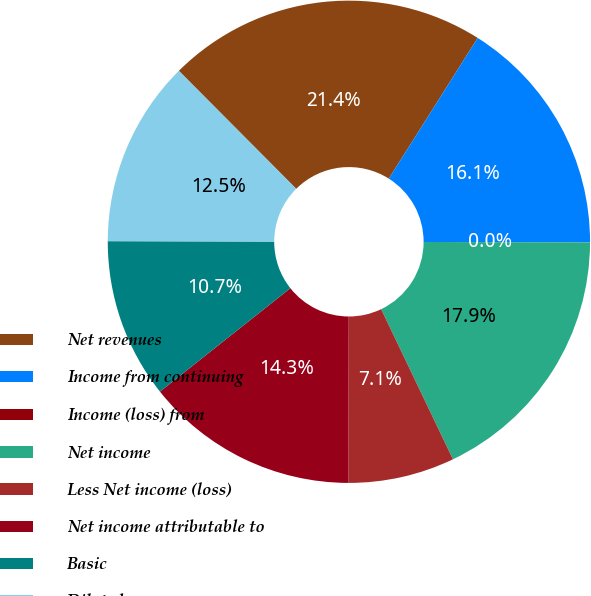<chart> <loc_0><loc_0><loc_500><loc_500><pie_chart><fcel>Net revenues<fcel>Income from continuing<fcel>Income (loss) from<fcel>Net income<fcel>Less Net income (loss)<fcel>Net income attributable to<fcel>Basic<fcel>Diluted<nl><fcel>21.43%<fcel>16.07%<fcel>0.0%<fcel>17.86%<fcel>7.14%<fcel>14.29%<fcel>10.71%<fcel>12.5%<nl></chart> 